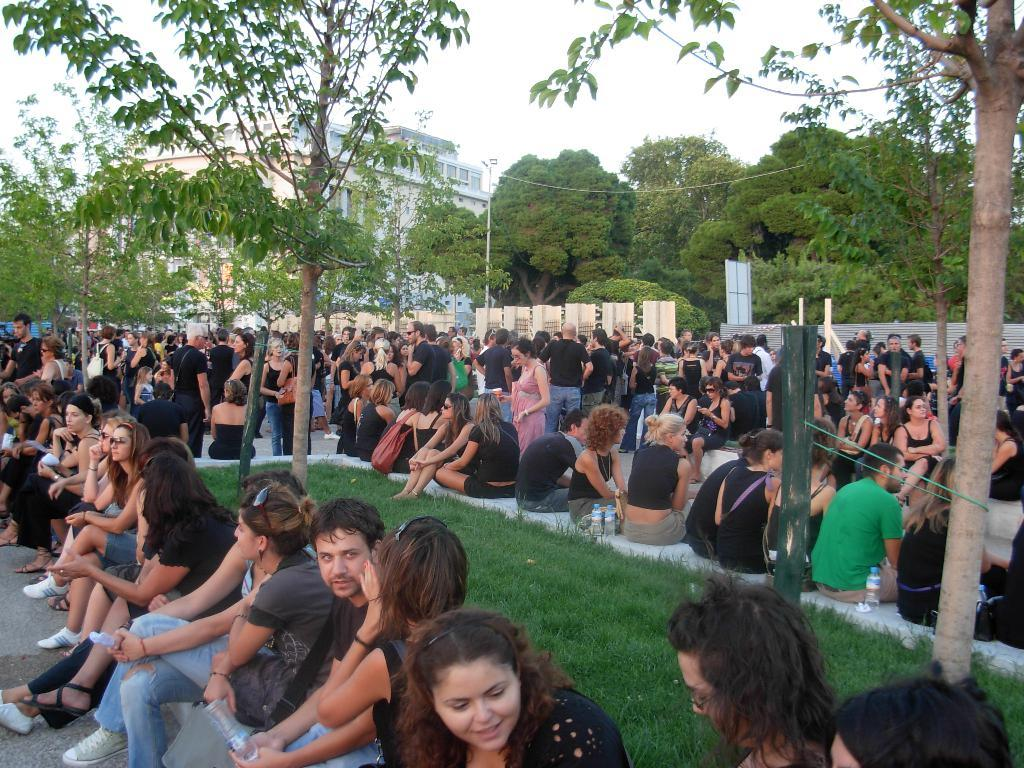What are the people in the image doing? The people in the image are sitting on the path. What objects can be seen on the path? There are bottles visible on the path. What can be seen in the background of the image? There are trees and a building in the background of the image. What type of powder is being used to create a thrilling effect in the image? There is no powder or thrilling effect present in the image. 